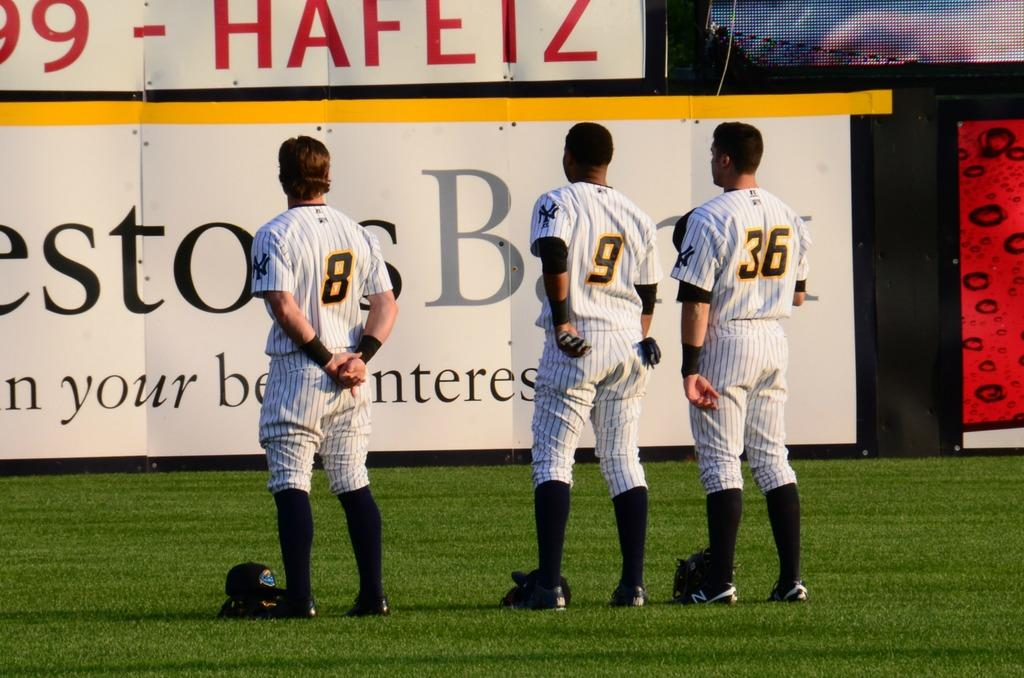What are the people in the image doing? The people in the image are standing, which suggests they might be players. What can be seen in the background of the image? There are hoardings with text in the background of the image. What type of surface is visible at the bottom of the image? There is grass visible at the bottom of the image. What type of horn can be heard in the image? There is no horn present in the image, so it cannot be heard. 